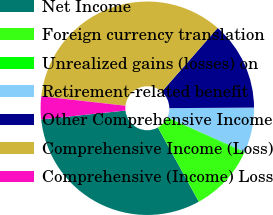Convert chart to OTSL. <chart><loc_0><loc_0><loc_500><loc_500><pie_chart><fcel>Net Income<fcel>Foreign currency translation<fcel>Unrealized gains (losses) on<fcel>Retirement-related benefit<fcel>Other Comprehensive Income<fcel>Comprehensive Income (Loss)<fcel>Comprehensive (Income) Loss<nl><fcel>31.34%<fcel>10.13%<fcel>0.15%<fcel>6.8%<fcel>13.45%<fcel>34.66%<fcel>3.47%<nl></chart> 